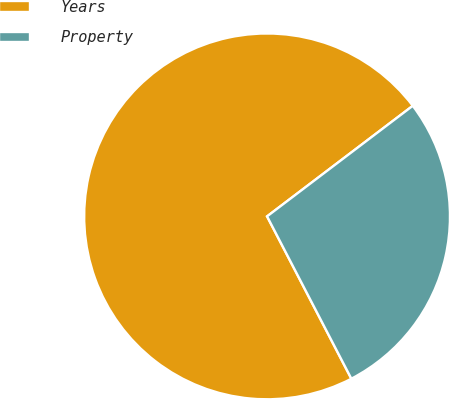<chart> <loc_0><loc_0><loc_500><loc_500><pie_chart><fcel>Years<fcel>Property<nl><fcel>72.29%<fcel>27.71%<nl></chart> 